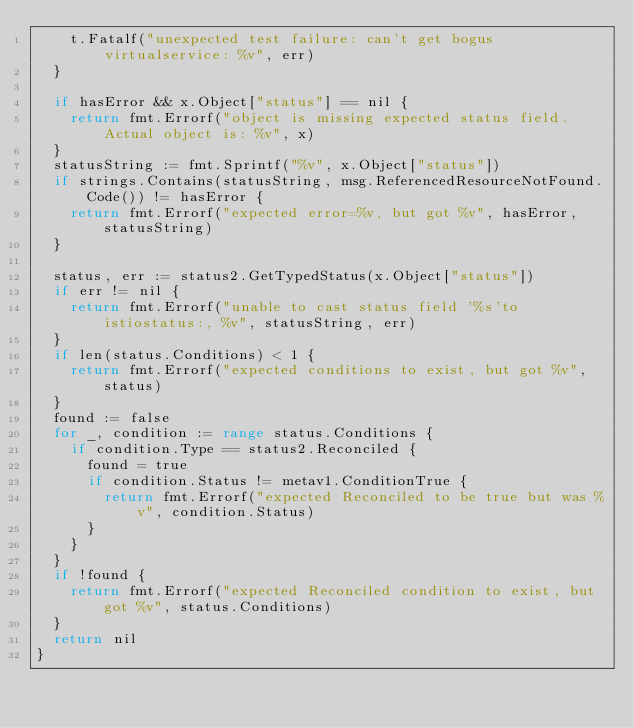<code> <loc_0><loc_0><loc_500><loc_500><_Go_>		t.Fatalf("unexpected test failure: can't get bogus virtualservice: %v", err)
	}

	if hasError && x.Object["status"] == nil {
		return fmt.Errorf("object is missing expected status field.  Actual object is: %v", x)
	}
	statusString := fmt.Sprintf("%v", x.Object["status"])
	if strings.Contains(statusString, msg.ReferencedResourceNotFound.Code()) != hasError {
		return fmt.Errorf("expected error=%v, but got %v", hasError, statusString)
	}

	status, err := status2.GetTypedStatus(x.Object["status"])
	if err != nil {
		return fmt.Errorf("unable to cast status field '%s'to istiostatus:, %v", statusString, err)
	}
	if len(status.Conditions) < 1 {
		return fmt.Errorf("expected conditions to exist, but got %v", status)
	}
	found := false
	for _, condition := range status.Conditions {
		if condition.Type == status2.Reconciled {
			found = true
			if condition.Status != metav1.ConditionTrue {
				return fmt.Errorf("expected Reconciled to be true but was %v", condition.Status)
			}
		}
	}
	if !found {
		return fmt.Errorf("expected Reconciled condition to exist, but got %v", status.Conditions)
	}
	return nil
}
</code> 